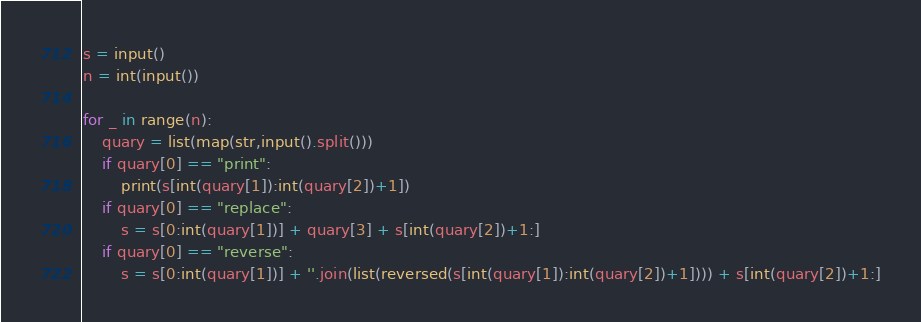<code> <loc_0><loc_0><loc_500><loc_500><_Python_>s = input()
n = int(input())

for _ in range(n):
    quary = list(map(str,input().split()))
    if quary[0] == "print":
        print(s[int(quary[1]):int(quary[2])+1])
    if quary[0] == "replace":
        s = s[0:int(quary[1])] + quary[3] + s[int(quary[2])+1:]
    if quary[0] == "reverse":
        s = s[0:int(quary[1])] + ''.join(list(reversed(s[int(quary[1]):int(quary[2])+1]))) + s[int(quary[2])+1:]
</code> 